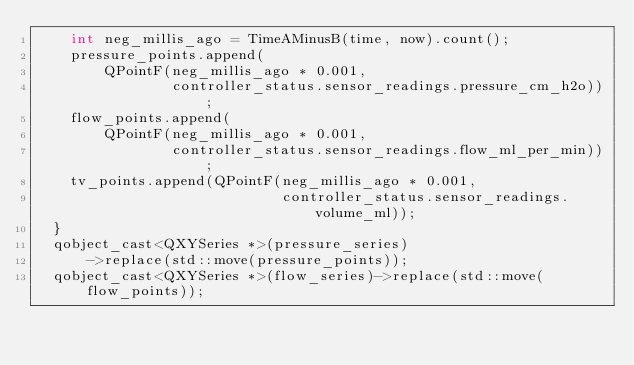Convert code to text. <code><loc_0><loc_0><loc_500><loc_500><_C++_>    int neg_millis_ago = TimeAMinusB(time, now).count();
    pressure_points.append(
        QPointF(neg_millis_ago * 0.001,
                controller_status.sensor_readings.pressure_cm_h2o));
    flow_points.append(
        QPointF(neg_millis_ago * 0.001,
                controller_status.sensor_readings.flow_ml_per_min));
    tv_points.append(QPointF(neg_millis_ago * 0.001,
                             controller_status.sensor_readings.volume_ml));
  }
  qobject_cast<QXYSeries *>(pressure_series)
      ->replace(std::move(pressure_points));
  qobject_cast<QXYSeries *>(flow_series)->replace(std::move(flow_points));</code> 